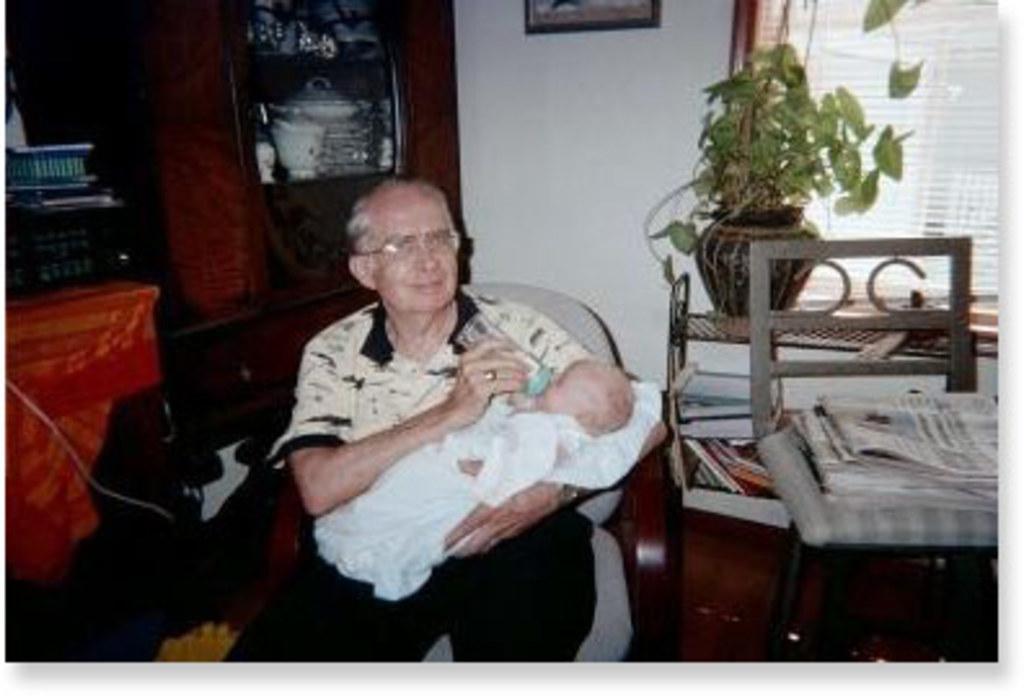In one or two sentences, can you explain what this image depicts? In this image, in the middle there is a man, he is holding a baby. In the background there are shelves, books, chair, papers, plant, wardrobe, vessels, photo frame, window and a wall. 